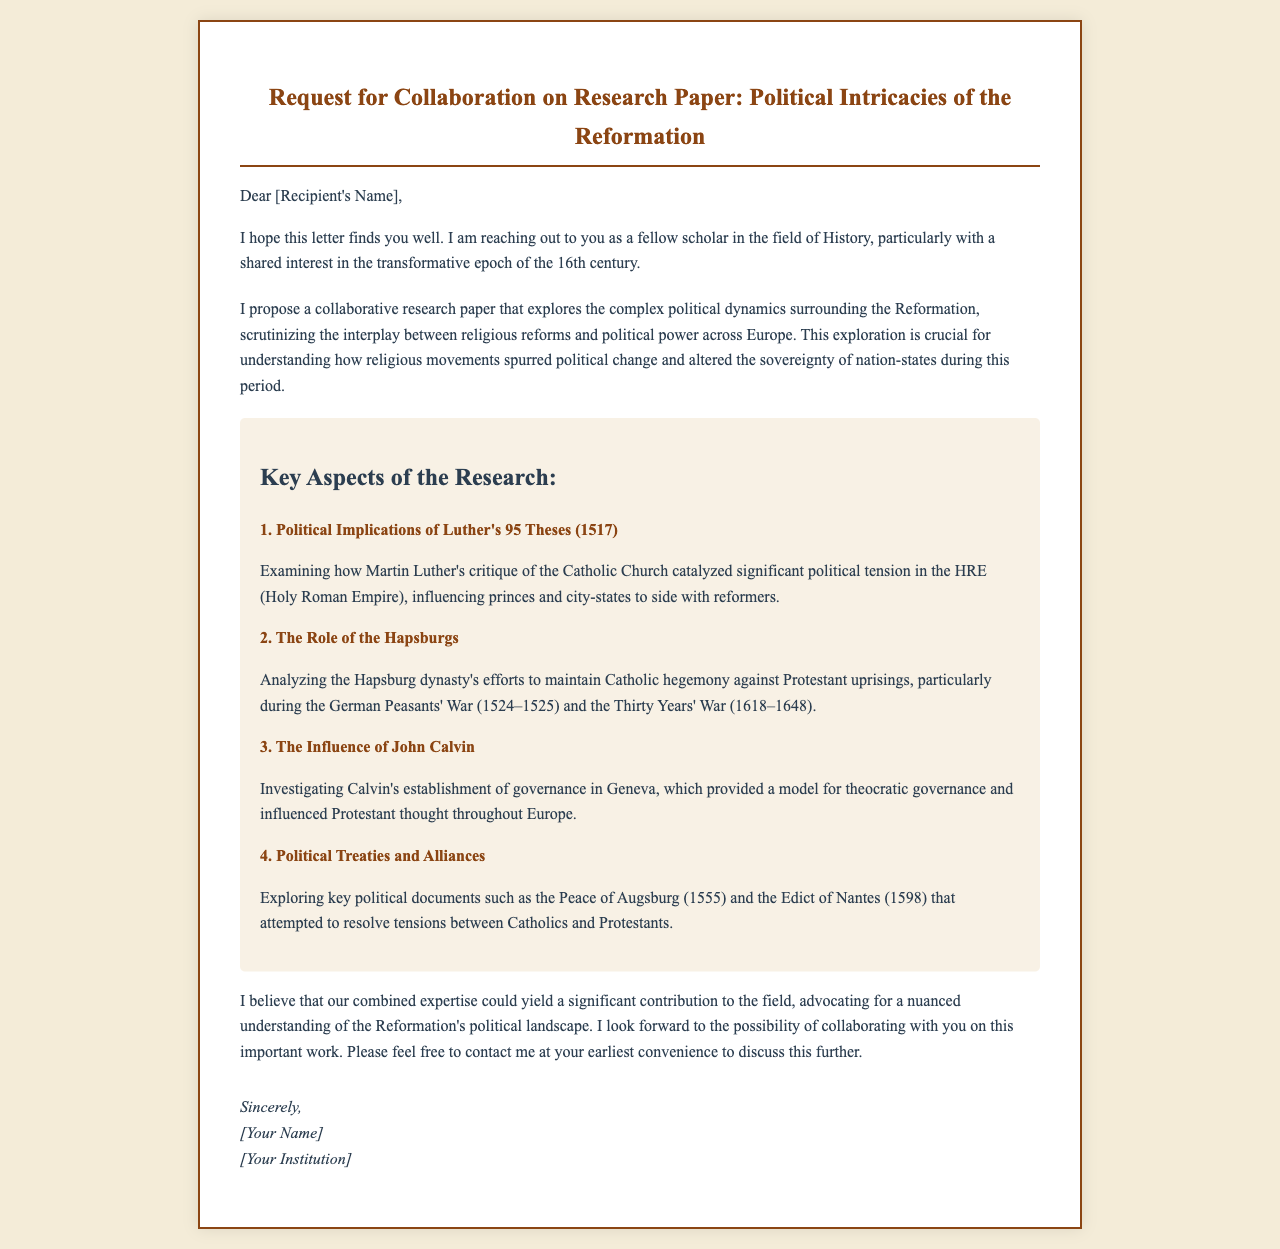What is the title of the collaboration request? The title states the purpose of the document, which is a request for collaboration on a research paper.
Answer: Request for Collaboration on Research Paper: Political Intricacies of the Reformation Who is the author reaching out to? The document addresses another scholar, although the specific name is a placeholder.
Answer: [Recipient's Name] What year did Martin Luther publish his 95 Theses? The document refers to the significant year when Luther's critique was made.
Answer: 1517 What is one key political document mentioned? The document lists important treaties in the context of religious conflicts.
Answer: Peace of Augsburg (1555) What dynasty is analyzed for its role in maintaining Catholic hegemony? The document discusses the efforts of a specific royal family during the Reformation.
Answer: Hapsburgs How many key aspects of the research are highlighted? The document outlines multiple areas of focus for the proposed research paper.
Answer: 4 What concept does Calvin's governance in Geneva represent? The document refers to a specific model of governance influenced by Calvin.
Answer: Theocratic governance What event is associated with the German Peasants' War? The document connects a significant uprising to the political landscape of the Reformation.
Answer: 1524-1525 